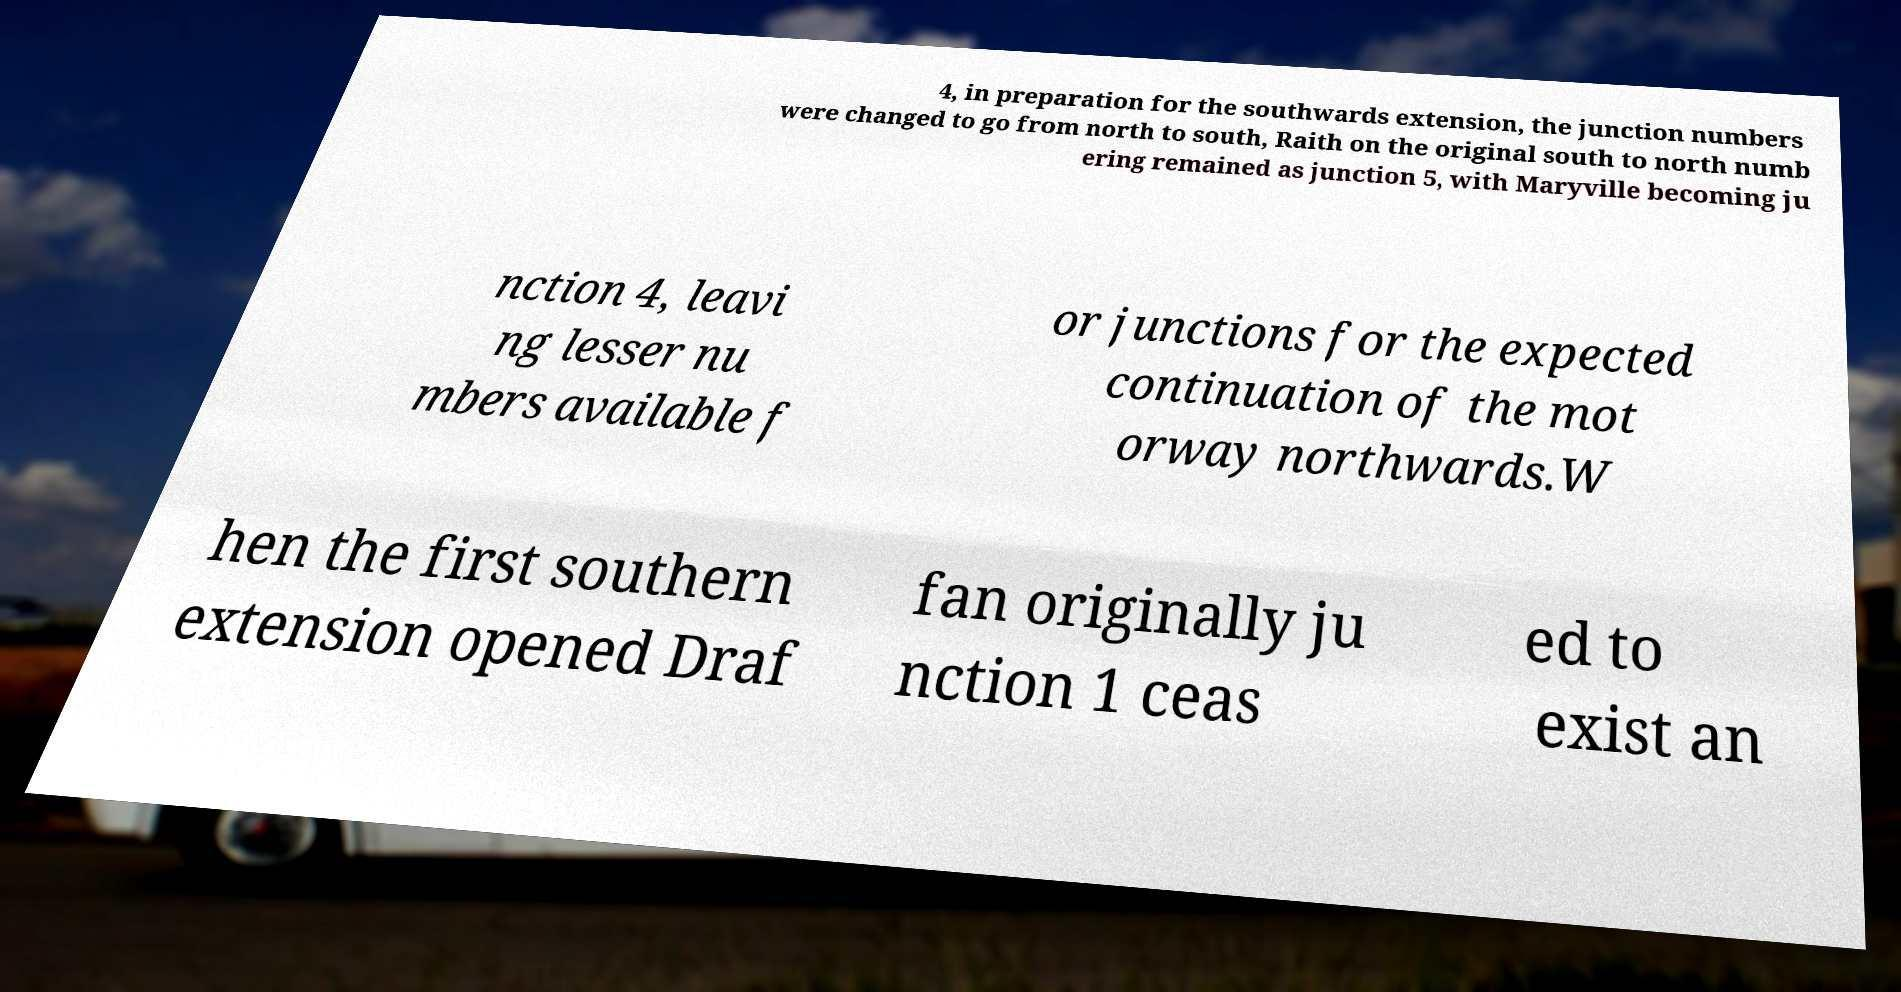I need the written content from this picture converted into text. Can you do that? 4, in preparation for the southwards extension, the junction numbers were changed to go from north to south, Raith on the original south to north numb ering remained as junction 5, with Maryville becoming ju nction 4, leavi ng lesser nu mbers available f or junctions for the expected continuation of the mot orway northwards.W hen the first southern extension opened Draf fan originally ju nction 1 ceas ed to exist an 